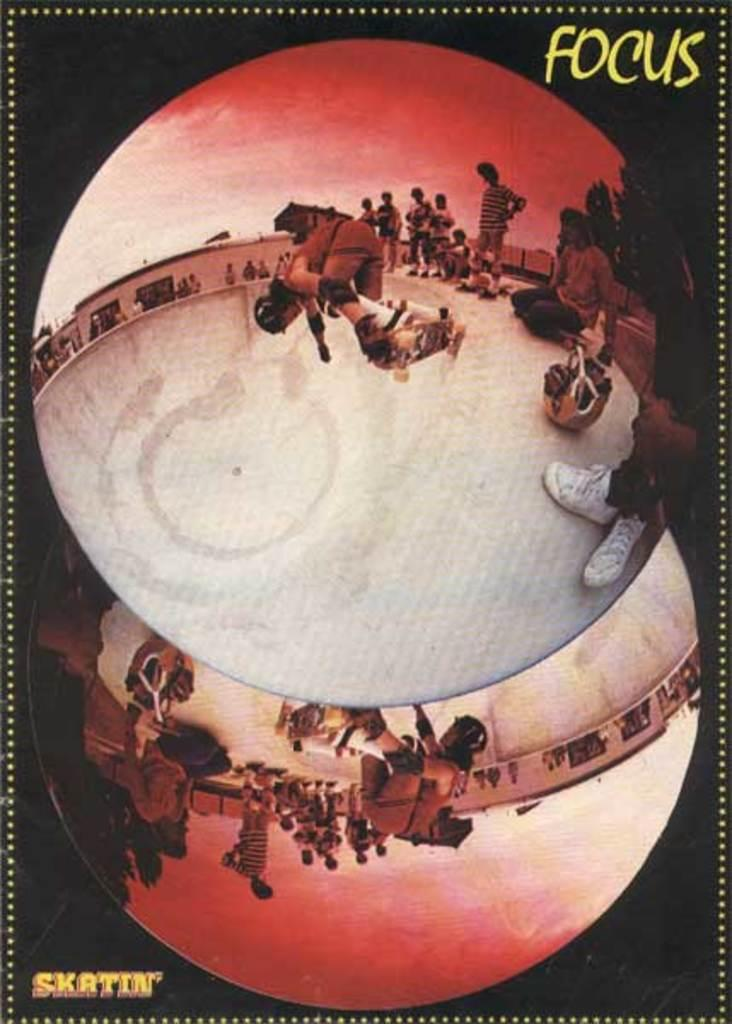<image>
Render a clear and concise summary of the photo. A poster from Skatin' magazine showing skateboarders doing tricks at a skate park. 